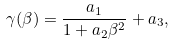<formula> <loc_0><loc_0><loc_500><loc_500>\gamma ( \beta ) = \frac { a _ { 1 } } { 1 + a _ { 2 } \beta ^ { 2 } } + a _ { 3 } ,</formula> 